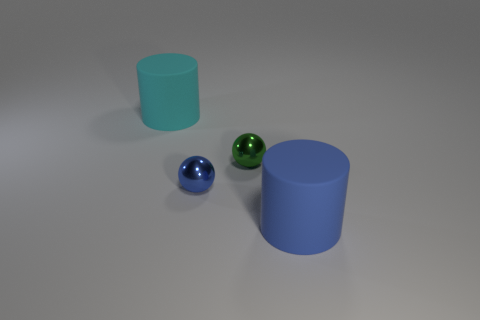What is the size of the blue shiny sphere?
Make the answer very short. Small. What number of objects are big blue cylinders or big cyan things?
Your answer should be very brief. 2. There is a rubber cylinder that is on the left side of the blue cylinder; what is its size?
Ensure brevity in your answer.  Large. Is there any other thing that has the same size as the cyan matte thing?
Offer a terse response. Yes. The thing that is both behind the tiny blue thing and in front of the cyan rubber object is what color?
Keep it short and to the point. Green. Is the material of the object that is in front of the blue shiny sphere the same as the cyan thing?
Provide a succinct answer. Yes. There is a cyan cylinder; are there any large matte objects behind it?
Make the answer very short. No. There is a ball that is in front of the green thing; is its size the same as the rubber cylinder that is on the left side of the big blue rubber thing?
Your answer should be compact. No. Are there any blue matte things that have the same size as the cyan thing?
Provide a short and direct response. Yes. Is the shape of the large thing in front of the blue metallic thing the same as  the blue metallic object?
Your response must be concise. No. 